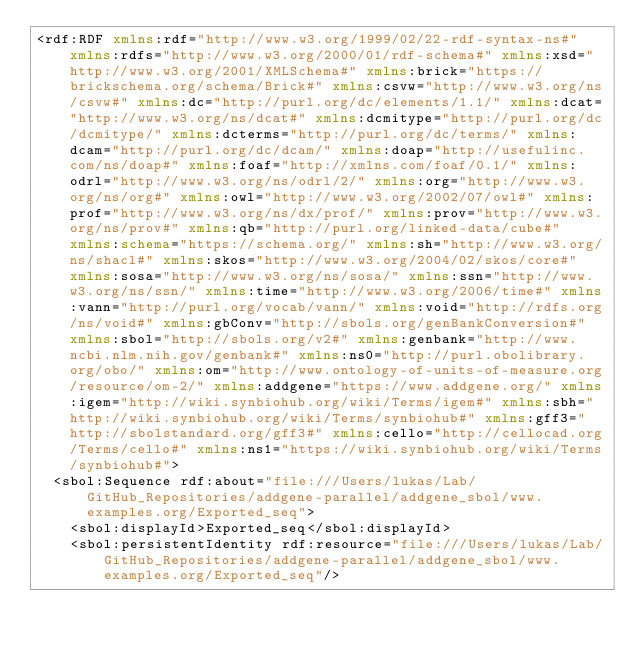<code> <loc_0><loc_0><loc_500><loc_500><_XML_><rdf:RDF xmlns:rdf="http://www.w3.org/1999/02/22-rdf-syntax-ns#" xmlns:rdfs="http://www.w3.org/2000/01/rdf-schema#" xmlns:xsd="http://www.w3.org/2001/XMLSchema#" xmlns:brick="https://brickschema.org/schema/Brick#" xmlns:csvw="http://www.w3.org/ns/csvw#" xmlns:dc="http://purl.org/dc/elements/1.1/" xmlns:dcat="http://www.w3.org/ns/dcat#" xmlns:dcmitype="http://purl.org/dc/dcmitype/" xmlns:dcterms="http://purl.org/dc/terms/" xmlns:dcam="http://purl.org/dc/dcam/" xmlns:doap="http://usefulinc.com/ns/doap#" xmlns:foaf="http://xmlns.com/foaf/0.1/" xmlns:odrl="http://www.w3.org/ns/odrl/2/" xmlns:org="http://www.w3.org/ns/org#" xmlns:owl="http://www.w3.org/2002/07/owl#" xmlns:prof="http://www.w3.org/ns/dx/prof/" xmlns:prov="http://www.w3.org/ns/prov#" xmlns:qb="http://purl.org/linked-data/cube#" xmlns:schema="https://schema.org/" xmlns:sh="http://www.w3.org/ns/shacl#" xmlns:skos="http://www.w3.org/2004/02/skos/core#" xmlns:sosa="http://www.w3.org/ns/sosa/" xmlns:ssn="http://www.w3.org/ns/ssn/" xmlns:time="http://www.w3.org/2006/time#" xmlns:vann="http://purl.org/vocab/vann/" xmlns:void="http://rdfs.org/ns/void#" xmlns:gbConv="http://sbols.org/genBankConversion#" xmlns:sbol="http://sbols.org/v2#" xmlns:genbank="http://www.ncbi.nlm.nih.gov/genbank#" xmlns:ns0="http://purl.obolibrary.org/obo/" xmlns:om="http://www.ontology-of-units-of-measure.org/resource/om-2/" xmlns:addgene="https://www.addgene.org/" xmlns:igem="http://wiki.synbiohub.org/wiki/Terms/igem#" xmlns:sbh="http://wiki.synbiohub.org/wiki/Terms/synbiohub#" xmlns:gff3="http://sbolstandard.org/gff3#" xmlns:cello="http://cellocad.org/Terms/cello#" xmlns:ns1="https://wiki.synbiohub.org/wiki/Terms/synbiohub#">
  <sbol:Sequence rdf:about="file:///Users/lukas/Lab/GitHub_Repositories/addgene-parallel/addgene_sbol/www.examples.org/Exported_seq">
    <sbol:displayId>Exported_seq</sbol:displayId>
    <sbol:persistentIdentity rdf:resource="file:///Users/lukas/Lab/GitHub_Repositories/addgene-parallel/addgene_sbol/www.examples.org/Exported_seq"/></code> 